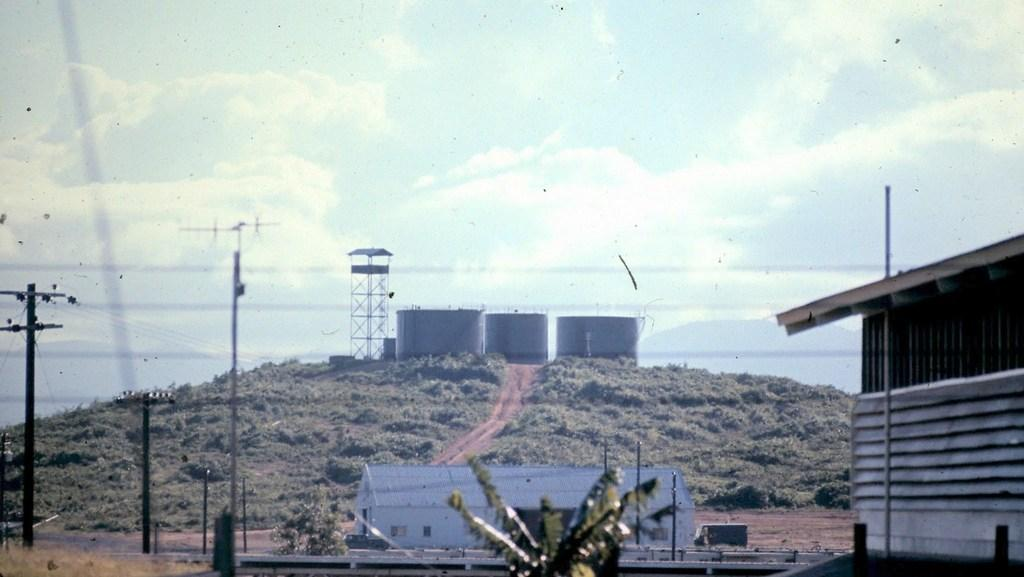What type of vegetation can be seen in the image? There are trees in the image. What type of structure is present in the image? There is a shed and a building in the image. What other objects can be seen in the image? There are poles and containers in the image. What is visible in the background of the image? The sky is visible in the background of the image. How many attempts does the tree make to trip the building in the image? There is no attempt by the tree to trip the building in the image, as trees do not have the ability to trip or interact with buildings in this manner. 